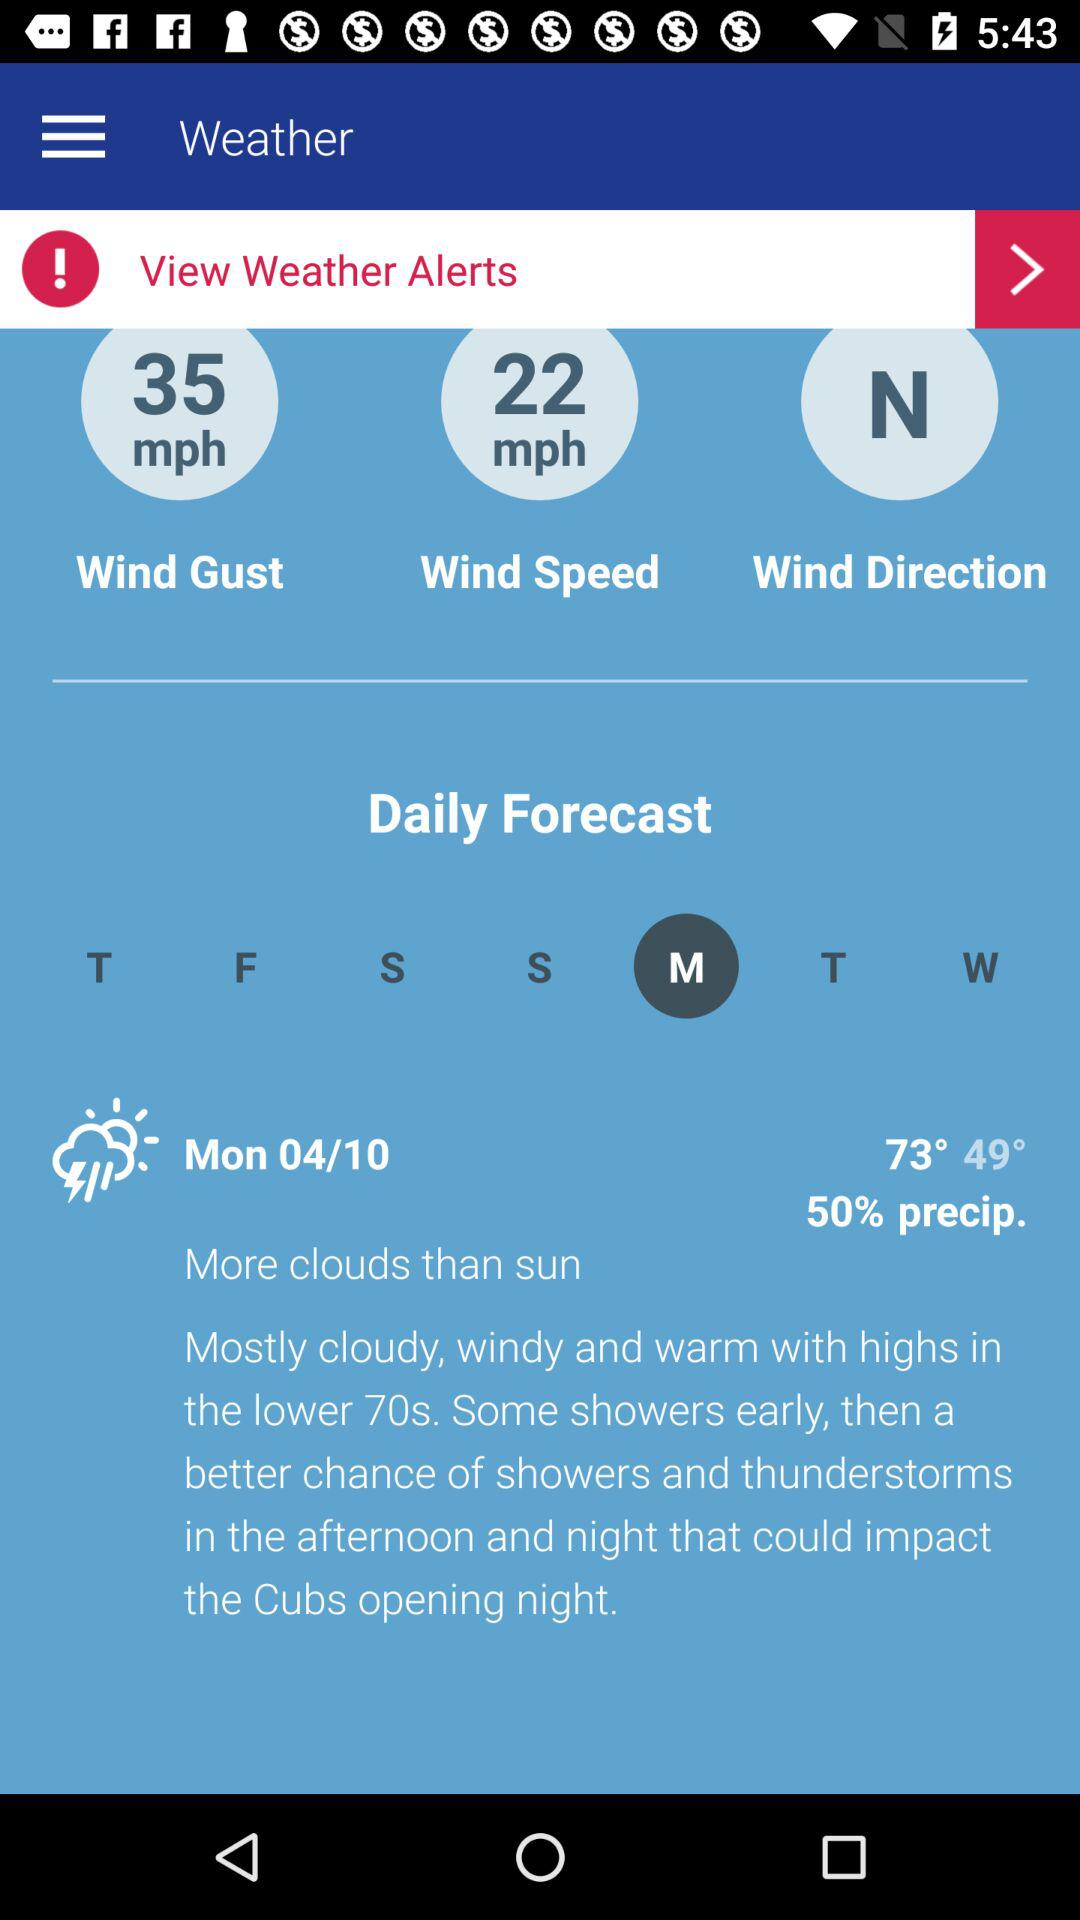What is the speed of the wind? The wind speed is 22 mph. 